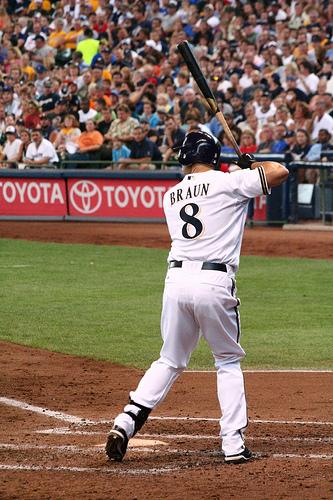What is the players name?
Keep it brief. Braun. What is the man holding?
Be succinct. Bat. What is the number on the Jersey?
Write a very short answer. 8. What number is on his jersey?
Quick response, please. 8. What is the player holding in his hand?
Short answer required. Bat. How many baseball players are in this picture?
Concise answer only. 1. What is the number on the shirt?
Answer briefly. 8. 